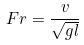<formula> <loc_0><loc_0><loc_500><loc_500>F r = \frac { v } { \sqrt { g l } }</formula> 